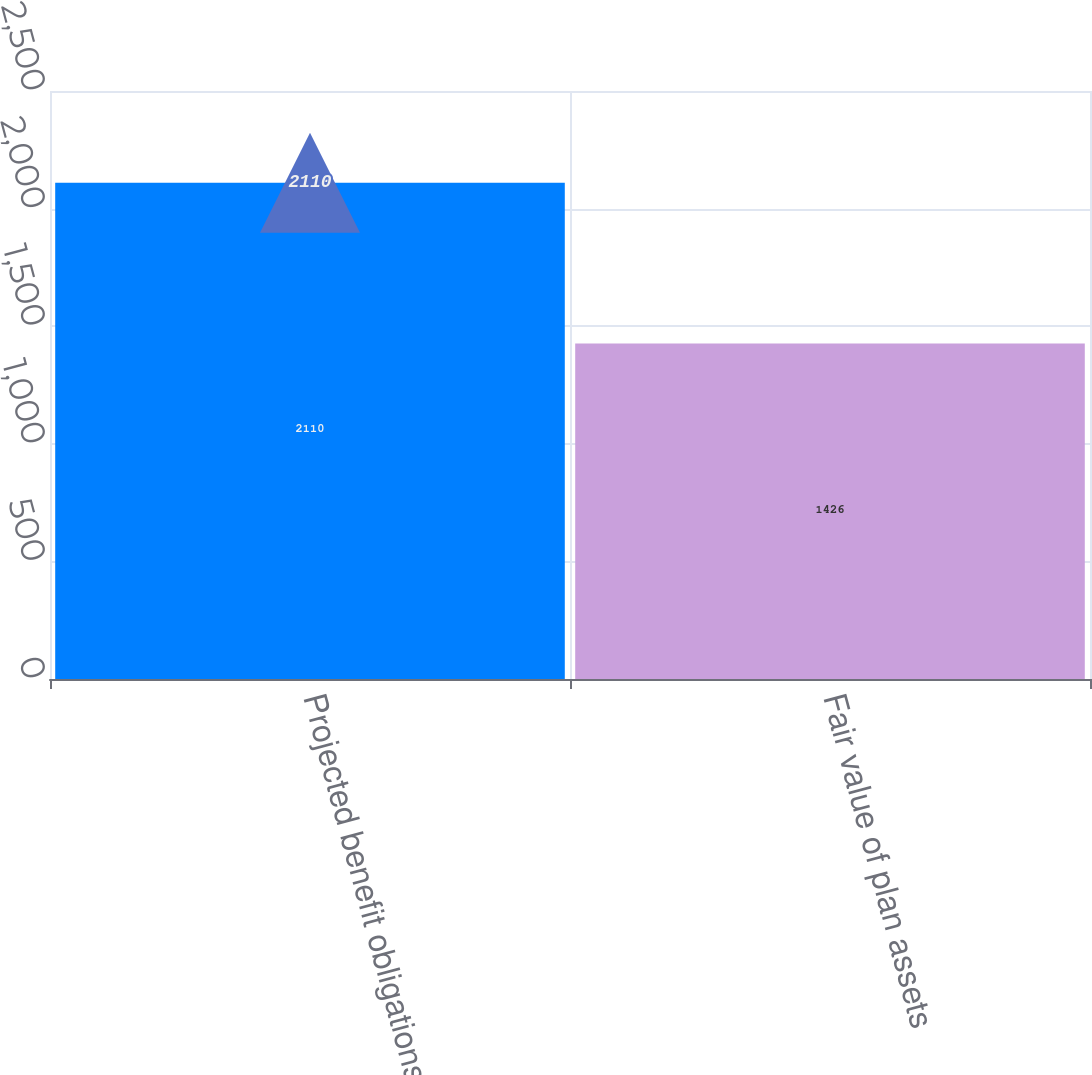Convert chart. <chart><loc_0><loc_0><loc_500><loc_500><bar_chart><fcel>Projected benefit obligations<fcel>Fair value of plan assets<nl><fcel>2110<fcel>1426<nl></chart> 